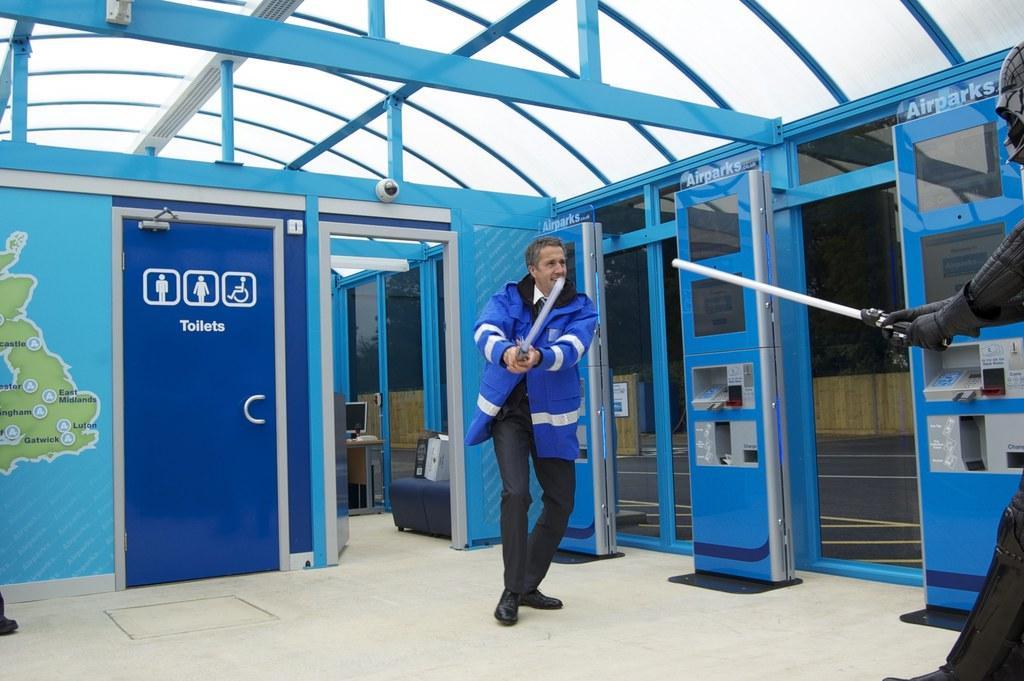Describe this image in one or two sentences. In this picture there are two people standing and holding the objects. At the back there is a computer on the table and there are objects on the chair and there is text on the wall and there is a cc camera on the wall. At the top there is a roof. At the bottom there is a floor. On the right side of the image there are trees and there is a wooden railing. 